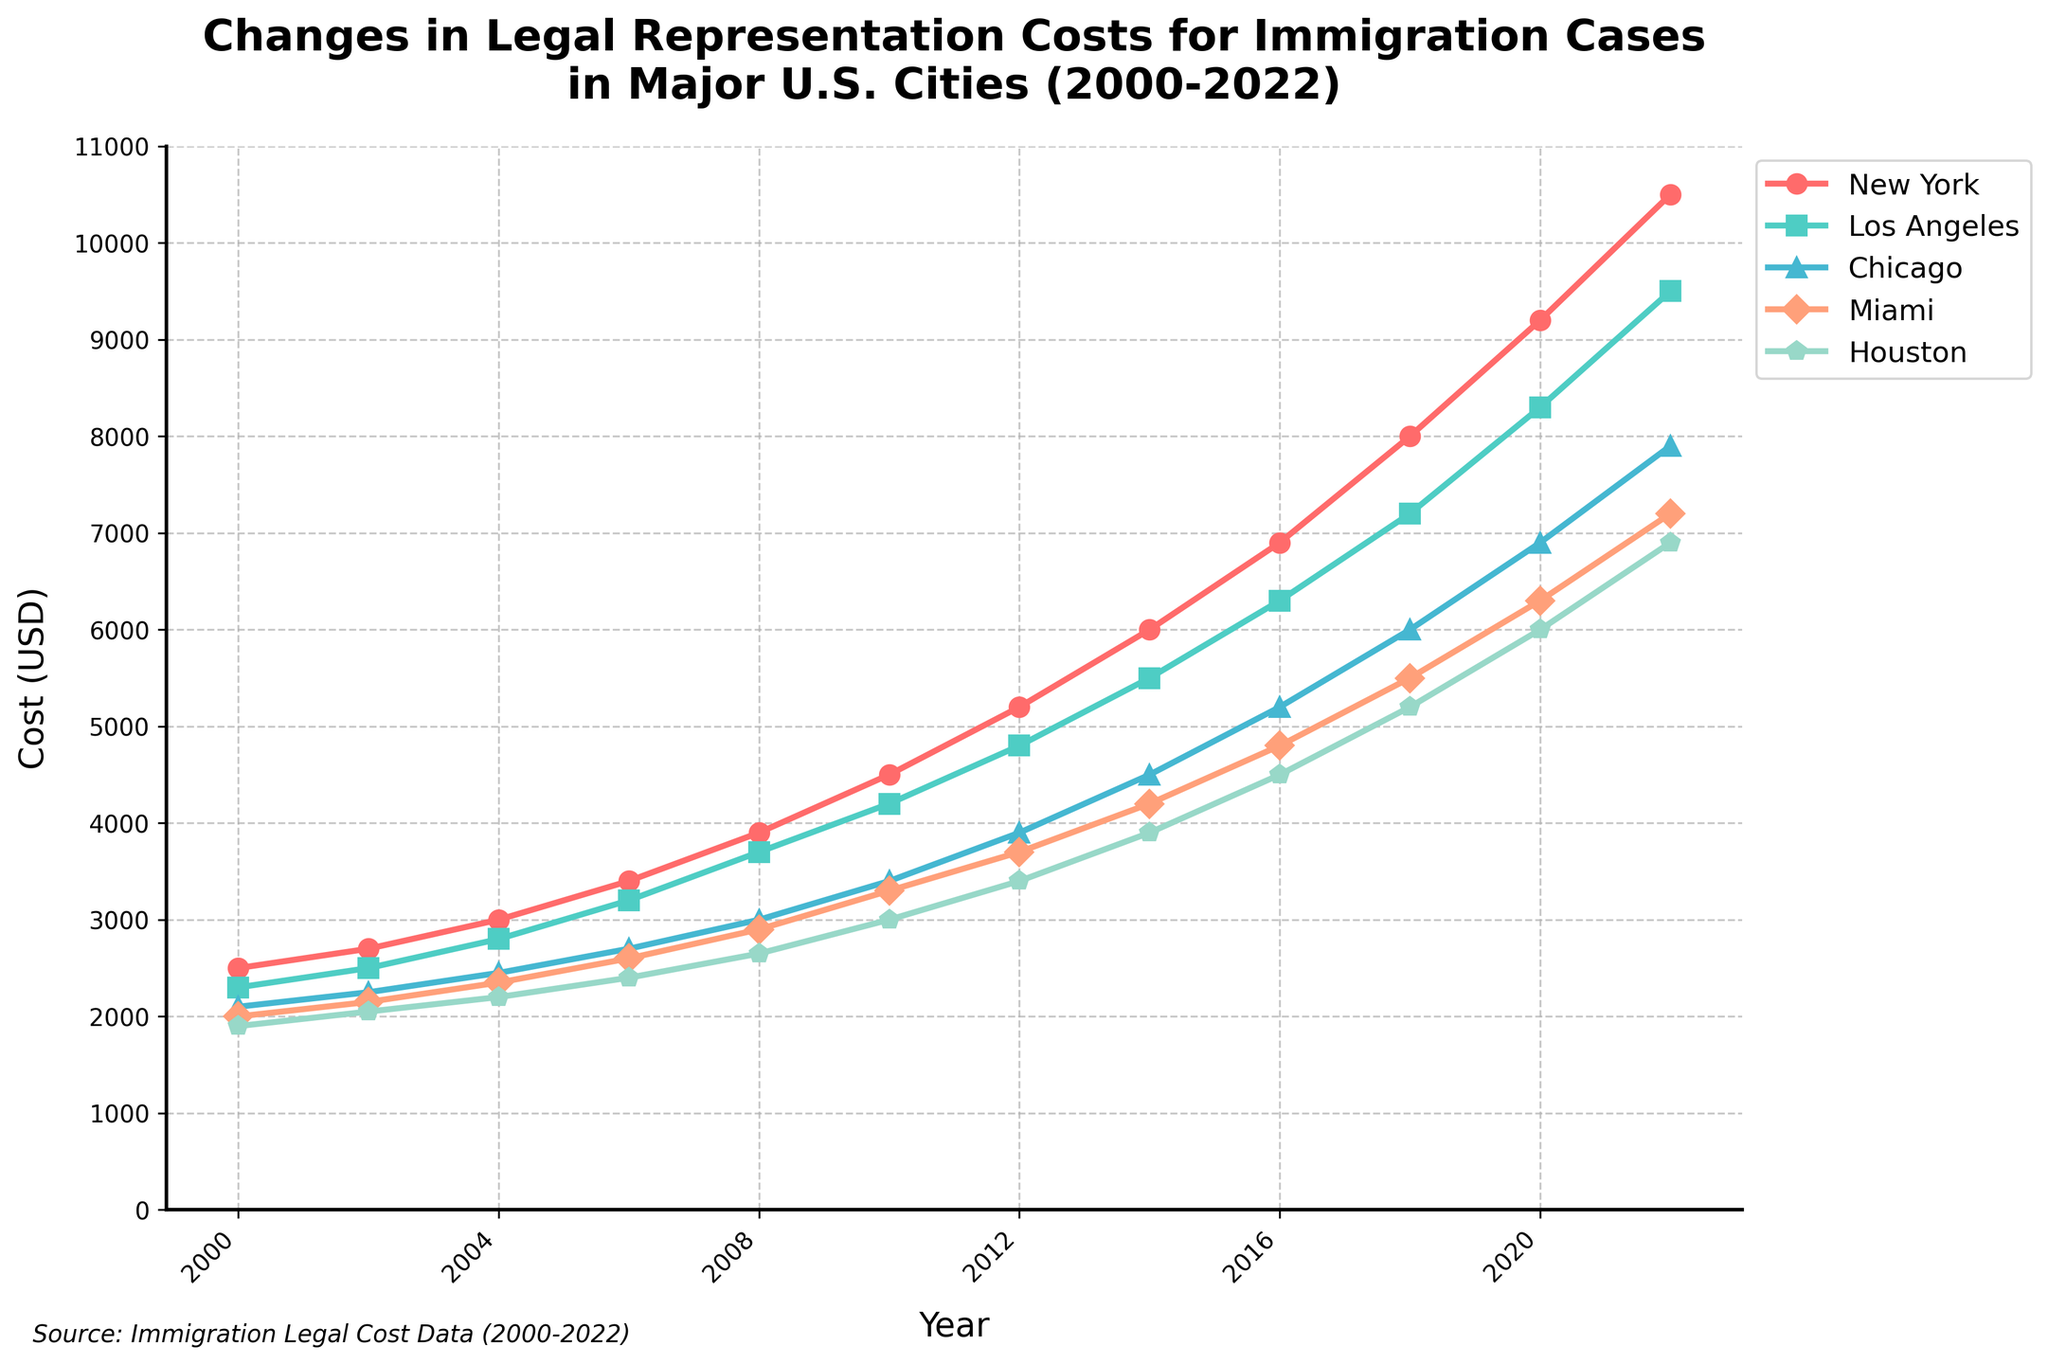What city had the highest legal representation cost for immigration cases in 2022? The plot shows that the highest cost in 2022 is in New York, as the line representing New York reaches the highest point on the y-axis.
Answer: New York By how much did the cost in New York increase from 2000 to 2022? In 2000, the cost in New York was $2500, and in 2022, it was $10500. The increase is calculated by subtracting the 2000 cost from the 2022 cost: 10500 - 2500 = 8000.
Answer: $8000 Which city had the smallest increase in legal representation costs from 2000 to 2022? First, calculate the increase for each city. New York: 10500 - 2500 = 8000, Los Angeles: 9500 - 2300 = 7200, Chicago: 7900 - 2100 = 5800, Miami: 7200 - 2000 = 5200, Houston: 6900 - 1900 = 5000. Houston had the smallest increase.
Answer: Houston What was the average cost of legal representation for immigration cases in 2020 across all cities? Add the costs for all cities in 2020 and divide by the number of cities: (9200 + 8300 + 6900 + 6300 + 6000) / 5 = 36700 / 5 = 7340.
Answer: $7340 Did the cost in Miami ever exceed the cost in Chicago? Throughout the years, the line for Miami remains below the line for Chicago, visually indicating that Miami's costs never exceeded those of Chicago.
Answer: No Which city had the fastest rate of cost increase from 2016 to 2020? Calculate the difference in costs from 2016 to 2020 for each city. New York: 9200 - 6900 = 2300, Los Angeles: 8300 - 6300 = 2000, Chicago: 6900 - 5200 = 1700, Miami: 6300 - 4800 = 1500, Houston: 6000 - 4500 = 1500. New York had the fastest rate of increase.
Answer: New York By how much did the cost of legal representation in Los Angeles increase between 2004 and 2014? In 2004, the cost in Los Angeles was $2800, and in 2014, it was $5500. The difference is 5500 - 2800 = 2700.
Answer: $2700 Which year saw the highest increase in costs across most cities? By visually assessing the slopes of the lines for each city, the year 2010 to 2012 shows significant increases in costs for New York, Los Angeles, Chicago, Miami, and Houston, indicating a steep rise in this period.
Answer: 2010-2012 What is the difference in costs between the highest and lowest cities in 2018? In 2018, the highest cost is in New York ($8000) and the lowest is in Houston ($5200). The difference is 8000 - 5200 = 2800.
Answer: $2800 